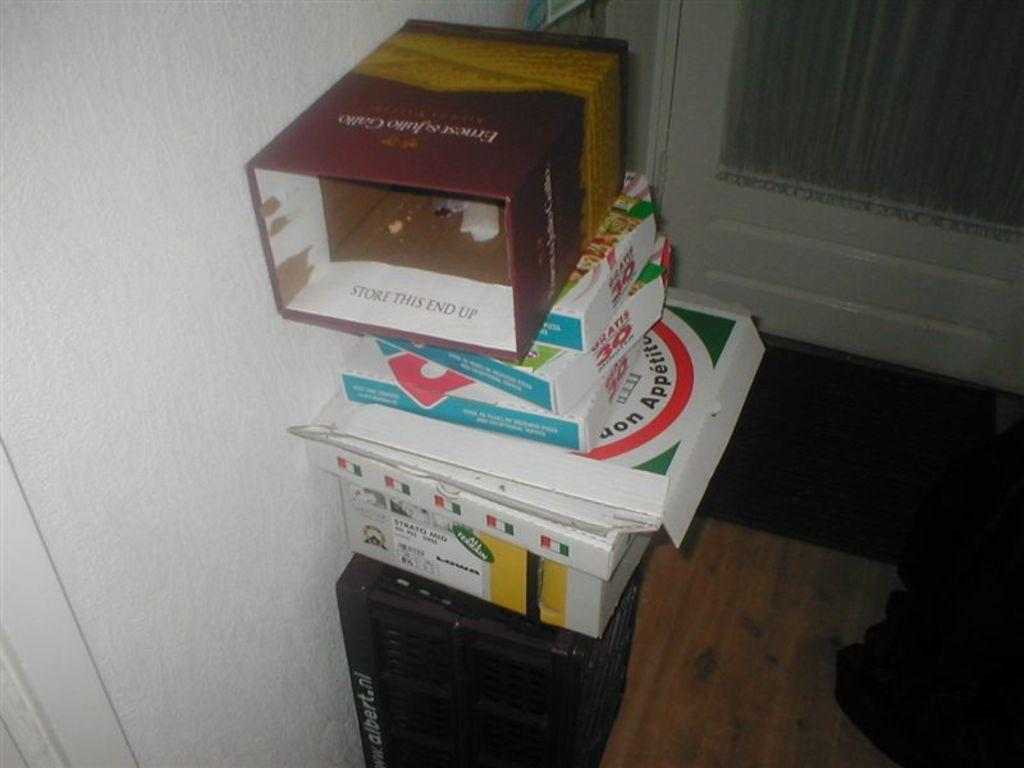<image>
Summarize the visual content of the image. A pile of boxes with the one at the bottom reading albert.nl 